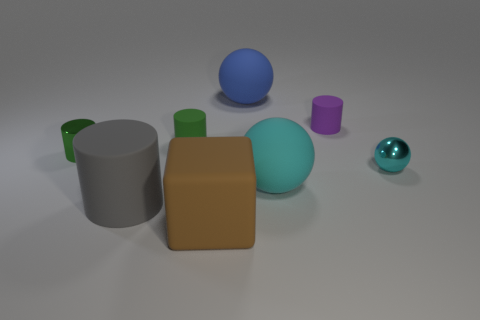What can you tell me about the texture and appearance of the objects? The objects in the image have a mix of textures. Most exhibit a matte finish, diffusing light softly and giving a muted appearance. There's a diversity in the colors, from pastel cyan to vibrant purple, contributing to a visually appealing variety. 